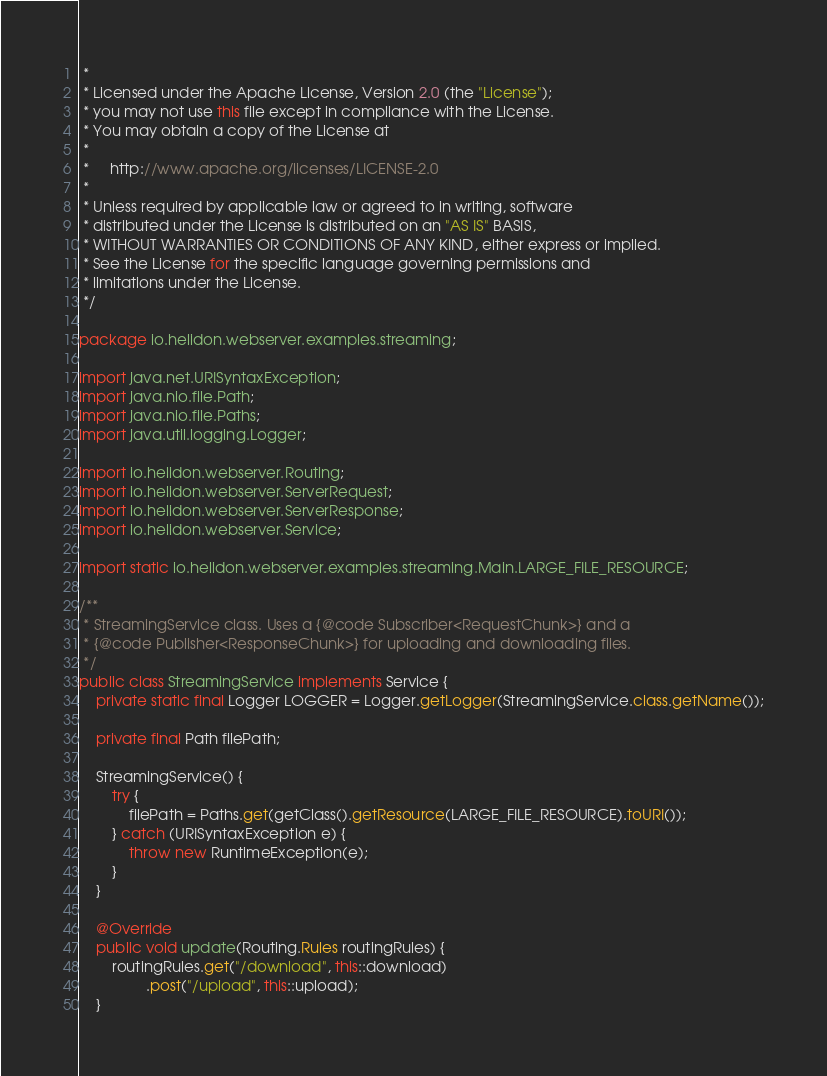Convert code to text. <code><loc_0><loc_0><loc_500><loc_500><_Java_> *
 * Licensed under the Apache License, Version 2.0 (the "License");
 * you may not use this file except in compliance with the License.
 * You may obtain a copy of the License at
 *
 *     http://www.apache.org/licenses/LICENSE-2.0
 *
 * Unless required by applicable law or agreed to in writing, software
 * distributed under the License is distributed on an "AS IS" BASIS,
 * WITHOUT WARRANTIES OR CONDITIONS OF ANY KIND, either express or implied.
 * See the License for the specific language governing permissions and
 * limitations under the License.
 */

package io.helidon.webserver.examples.streaming;

import java.net.URISyntaxException;
import java.nio.file.Path;
import java.nio.file.Paths;
import java.util.logging.Logger;

import io.helidon.webserver.Routing;
import io.helidon.webserver.ServerRequest;
import io.helidon.webserver.ServerResponse;
import io.helidon.webserver.Service;

import static io.helidon.webserver.examples.streaming.Main.LARGE_FILE_RESOURCE;

/**
 * StreamingService class. Uses a {@code Subscriber<RequestChunk>} and a
 * {@code Publisher<ResponseChunk>} for uploading and downloading files.
 */
public class StreamingService implements Service {
    private static final Logger LOGGER = Logger.getLogger(StreamingService.class.getName());

    private final Path filePath;

    StreamingService() {
        try {
            filePath = Paths.get(getClass().getResource(LARGE_FILE_RESOURCE).toURI());
        } catch (URISyntaxException e) {
            throw new RuntimeException(e);
        }
    }

    @Override
    public void update(Routing.Rules routingRules) {
        routingRules.get("/download", this::download)
                .post("/upload", this::upload);
    }
</code> 